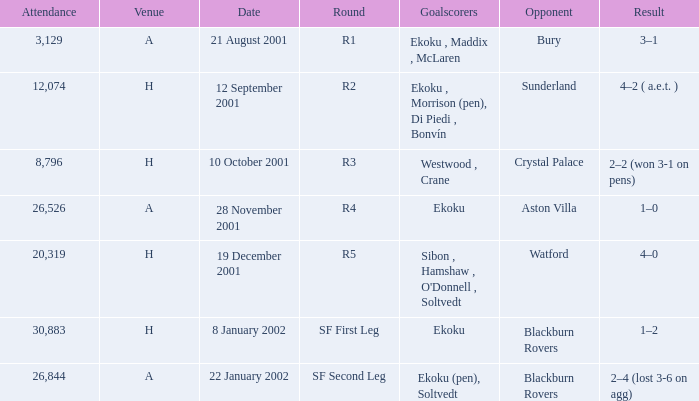I'm looking to parse the entire table for insights. Could you assist me with that? {'header': ['Attendance', 'Venue', 'Date', 'Round', 'Goalscorers', 'Opponent', 'Result'], 'rows': [['3,129', 'A', '21 August 2001', 'R1', 'Ekoku , Maddix , McLaren', 'Bury', '3–1'], ['12,074', 'H', '12 September 2001', 'R2', 'Ekoku , Morrison (pen), Di Piedi , Bonvín', 'Sunderland', '4–2 ( a.e.t. )'], ['8,796', 'H', '10 October 2001', 'R3', 'Westwood , Crane', 'Crystal Palace', '2–2 (won 3-1 on pens)'], ['26,526', 'A', '28 November 2001', 'R4', 'Ekoku', 'Aston Villa', '1–0'], ['20,319', 'H', '19 December 2001', 'R5', "Sibon , Hamshaw , O'Donnell , Soltvedt", 'Watford', '4–0'], ['30,883', 'H', '8 January 2002', 'SF First Leg', 'Ekoku', 'Blackburn Rovers', '1–2'], ['26,844', 'A', '22 January 2002', 'SF Second Leg', 'Ekoku (pen), Soltvedt', 'Blackburn Rovers', '2–4 (lost 3-6 on agg)']]} Which venue has attendance larger than 26,526, and sf first leg round? H. 